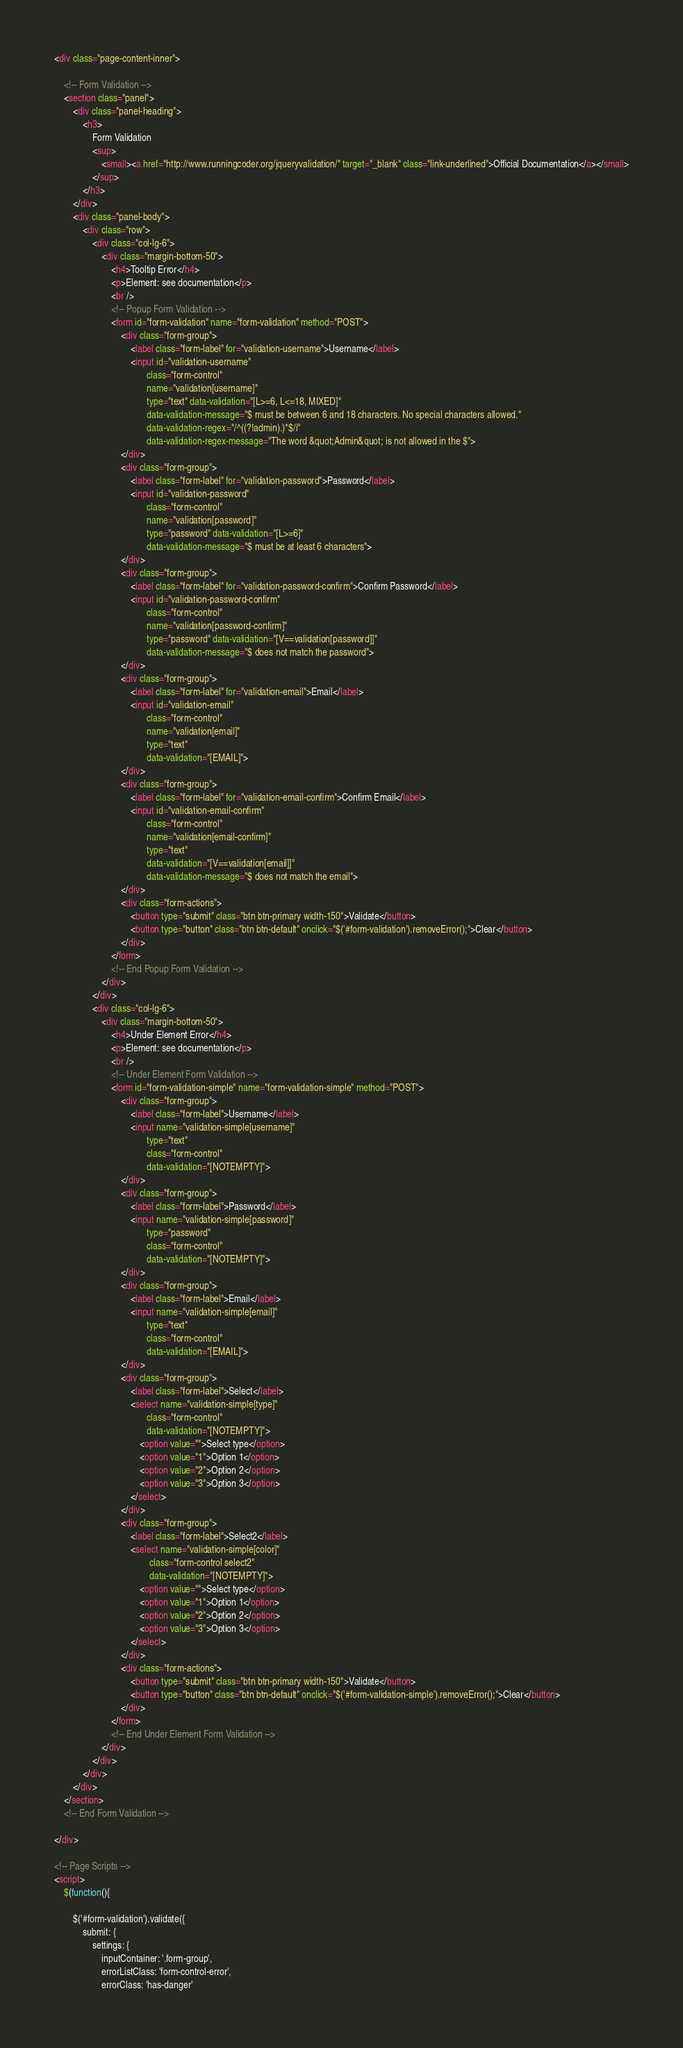Convert code to text. <code><loc_0><loc_0><loc_500><loc_500><_HTML_><div class="page-content-inner">

    <!-- Form Validation -->
    <section class="panel">
        <div class="panel-heading">
            <h3>
                Form Validation
                <sup>
                    <small><a href="http://www.runningcoder.org/jqueryvalidation/" target="_blank" class="link-underlined">Official Documentation</a></small>
                </sup>
            </h3>
        </div>
        <div class="panel-body">
            <div class="row">
                <div class="col-lg-6">
                    <div class="margin-bottom-50">
                        <h4>Tooltip Error</h4>
                        <p>Element: see documentation</p>
                        <br />
                        <!-- Popup Form Validation -->
                        <form id="form-validation" name="form-validation" method="POST">
                            <div class="form-group">
                                <label class="form-label" for="validation-username">Username</label>
                                <input id="validation-username"
                                       class="form-control"
                                       name="validation[username]"
                                       type="text" data-validation="[L>=6, L<=18, MIXED]"
                                       data-validation-message="$ must be between 6 and 18 characters. No special characters allowed."
                                       data-validation-regex="/^((?!admin).)*$/i"
                                       data-validation-regex-message="The word &quot;Admin&quot; is not allowed in the $">
                            </div>
                            <div class="form-group">
                                <label class="form-label" for="validation-password">Password</label>
                                <input id="validation-password"
                                       class="form-control"
                                       name="validation[password]"
                                       type="password" data-validation="[L>=6]"
                                       data-validation-message="$ must be at least 6 characters">
                            </div>
                            <div class="form-group">
                                <label class="form-label" for="validation-password-confirm">Confirm Password</label>
                                <input id="validation-password-confirm"
                                       class="form-control"
                                       name="validation[password-confirm]"
                                       type="password" data-validation="[V==validation[password]]"
                                       data-validation-message="$ does not match the password">
                            </div>
                            <div class="form-group">
                                <label class="form-label" for="validation-email">Email</label>
                                <input id="validation-email"
                                       class="form-control"
                                       name="validation[email]"
                                       type="text"
                                       data-validation="[EMAIL]">
                            </div>
                            <div class="form-group">
                                <label class="form-label" for="validation-email-confirm">Confirm Email</label>
                                <input id="validation-email-confirm"
                                       class="form-control"
                                       name="validation[email-confirm]"
                                       type="text"
                                       data-validation="[V==validation[email]]"
                                       data-validation-message="$ does not match the email">
                            </div>
                            <div class="form-actions">
                                <button type="submit" class="btn btn-primary width-150">Validate</button>
                                <button type="button" class="btn btn-default" onclick="$('#form-validation').removeError();">Clear</button>
                            </div>
                        </form>
                        <!-- End Popup Form Validation -->
                    </div>
                </div>
                <div class="col-lg-6">
                    <div class="margin-bottom-50">
                        <h4>Under Element Error</h4>
                        <p>Element: see documentation</p>
                        <br />
                        <!-- Under Element Form Validation -->
                        <form id="form-validation-simple" name="form-validation-simple" method="POST">
                            <div class="form-group">
                                <label class="form-label">Username</label>
                                <input name="validation-simple[username]"
                                       type="text"
                                       class="form-control"
                                       data-validation="[NOTEMPTY]">
                            </div>
                            <div class="form-group">
                                <label class="form-label">Password</label>
                                <input name="validation-simple[password]"
                                       type="password"
                                       class="form-control"
                                       data-validation="[NOTEMPTY]">
                            </div>
                            <div class="form-group">
                                <label class="form-label">Email</label>
                                <input name="validation-simple[email]"
                                       type="text"
                                       class="form-control"
                                       data-validation="[EMAIL]">
                            </div>
                            <div class="form-group">
                                <label class="form-label">Select</label>
                                <select name="validation-simple[type]"
                                       class="form-control"
                                       data-validation="[NOTEMPTY]">
                                    <option value="">Select type</option>
                                    <option value="1">Option 1</option>
                                    <option value="2">Option 2</option>
                                    <option value="3">Option 3</option>
                                </select>
                            </div>
                            <div class="form-group">
                                <label class="form-label">Select2</label>
                                <select name="validation-simple[color]"
                                        class="form-control select2"
                                        data-validation="[NOTEMPTY]">
                                    <option value="">Select type</option>
                                    <option value="1">Option 1</option>
                                    <option value="2">Option 2</option>
                                    <option value="3">Option 3</option>
                                </select>
                            </div>
                            <div class="form-actions">
                                <button type="submit" class="btn btn-primary width-150">Validate</button>
                                <button type="button" class="btn btn-default" onclick="$('#form-validation-simple').removeError();">Clear</button>
                            </div>
                        </form>
                        <!-- End Under Element Form Validation -->
                    </div>
                </div>
            </div>
        </div>
    </section>
    <!-- End Form Validation -->

</div>

<!-- Page Scripts -->
<script>
    $(function(){

        $('#form-validation').validate({
            submit: {
                settings: {
                    inputContainer: '.form-group',
                    errorListClass: 'form-control-error',
                    errorClass: 'has-danger'</code> 